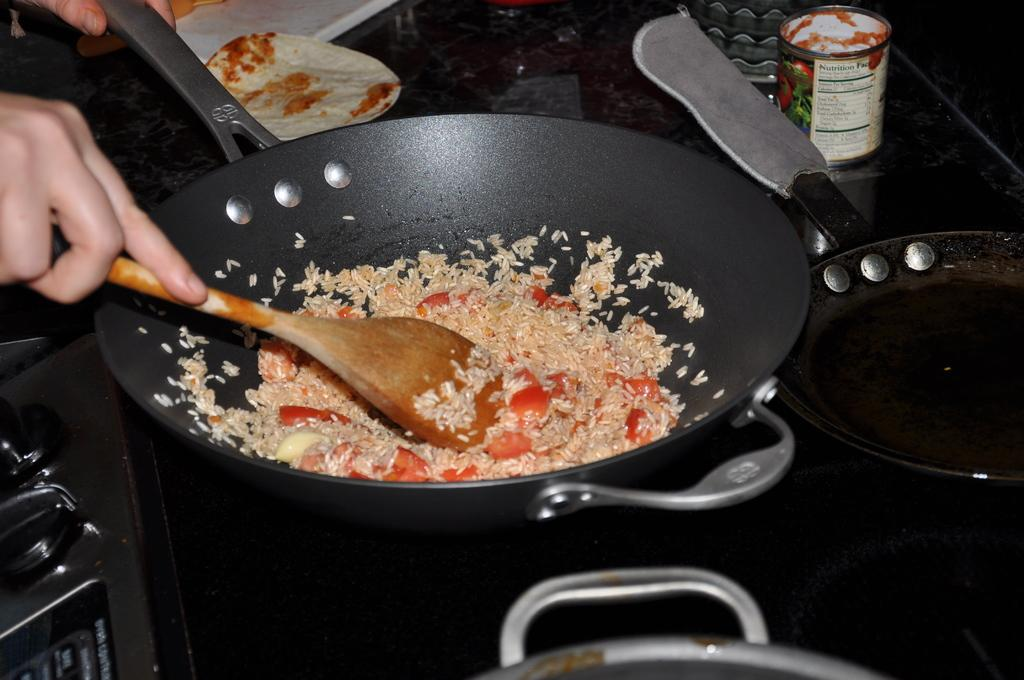What ingredients are in the vessel in the center of the image? There are tomatoes and rice in a vessel in the center of the image. What other kitchen items can be seen on the right side of the image? There is a jar, vessel, and pan on the right side of the image. Where is the stove located in the image? The stove is on the left side of the image. What type of temper can be seen in the image? There is no temper present in the image; it is a still image of kitchen items. 